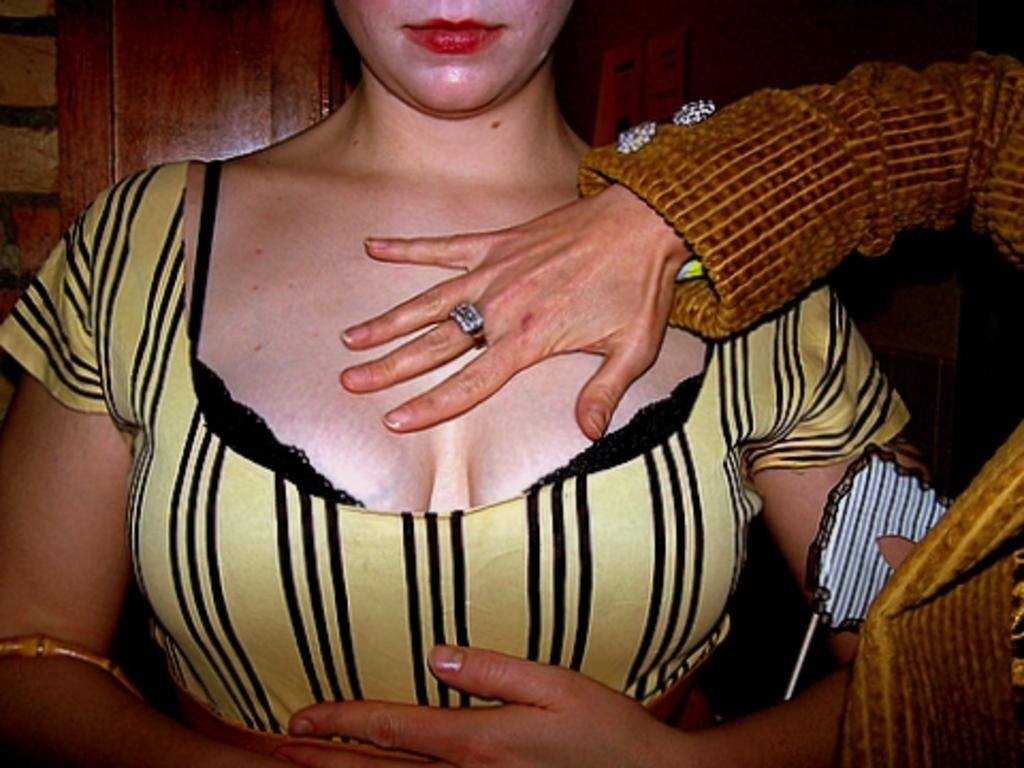What is the person on the left side of the image wearing? The person on the left side of the image is wearing a yellow and black dress. What is the person on the right side of the image wearing? The person on the right side of the image is wearing a brown coat. Can you describe the position of the person wearing the brown coat in the image? The person wearing the brown coat is on the right side of the image. What type of authority does the person wearing the yellow and black dress have in the image? There is no indication of authority in the image; it only shows two people wearing different clothing. 